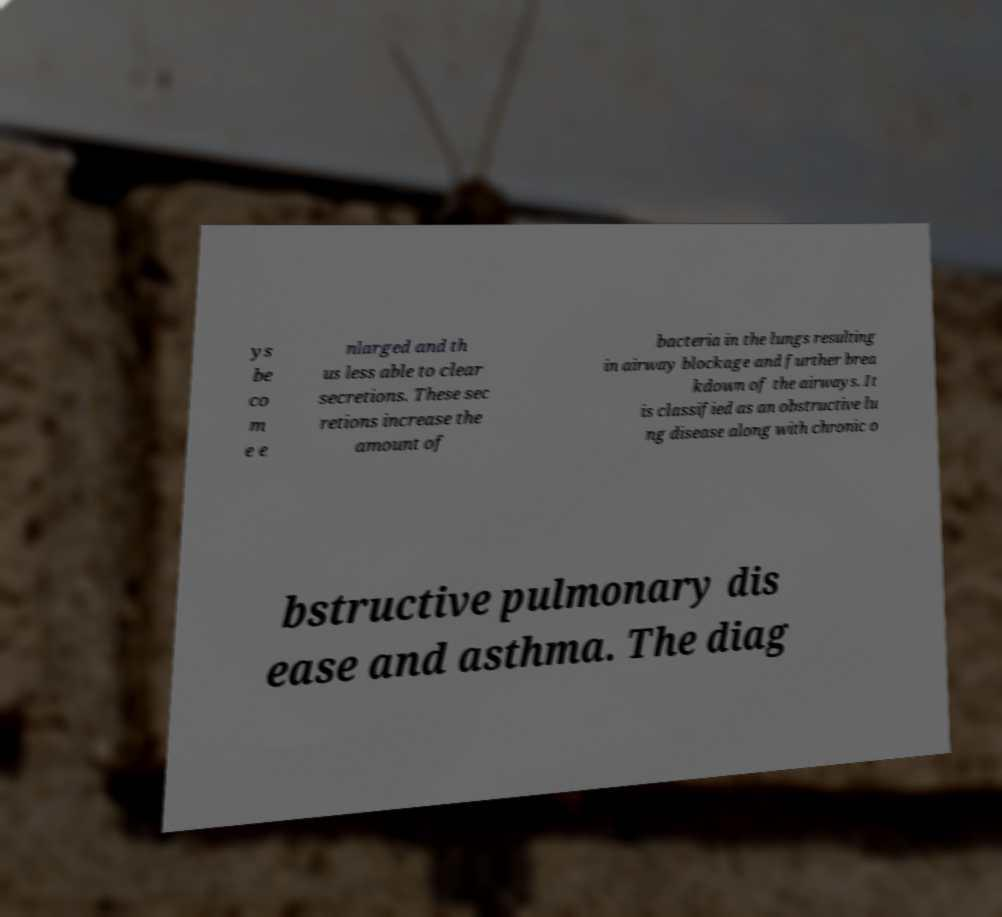For documentation purposes, I need the text within this image transcribed. Could you provide that? ys be co m e e nlarged and th us less able to clear secretions. These sec retions increase the amount of bacteria in the lungs resulting in airway blockage and further brea kdown of the airways. It is classified as an obstructive lu ng disease along with chronic o bstructive pulmonary dis ease and asthma. The diag 